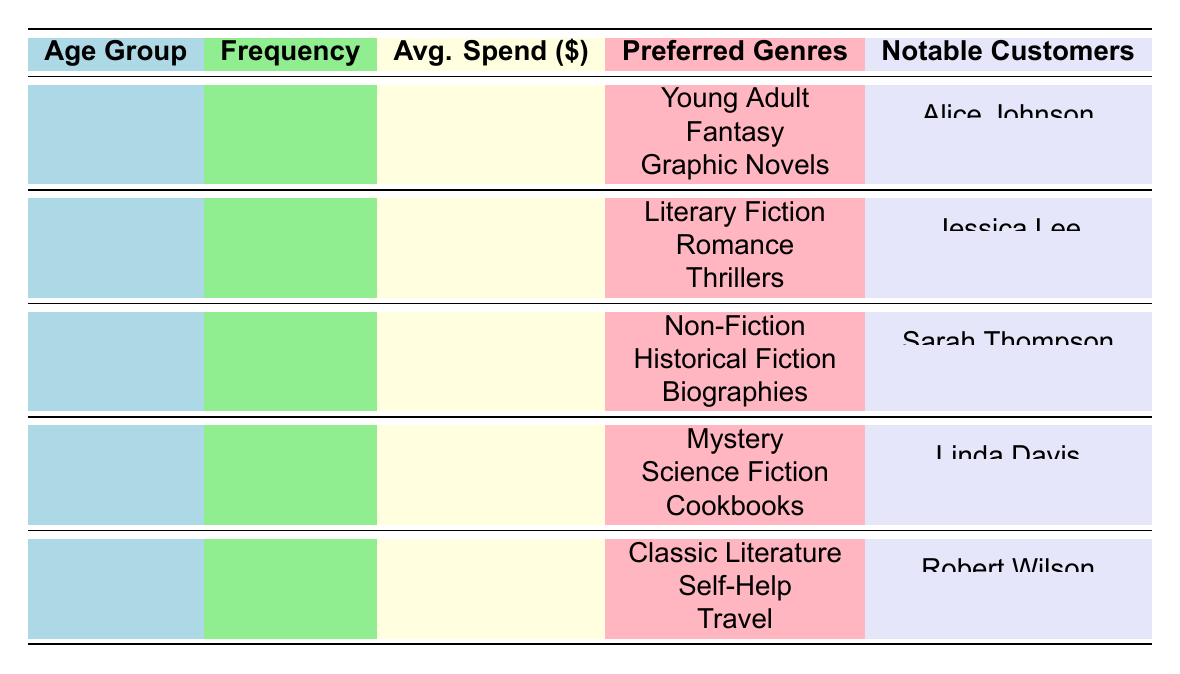What is the average spend for the 25-34 age group? The table shows that the average spend for the 25-34 age group is 45.
Answer: 45 Which age group purchases books weekly? By examining the frequency column, the 18-24 age group is the only group that purchases books weekly.
Answer: 18-24 How many notable customers are in the 35-44 age group? The 35-44 age group has two notable customers listed in the table: Sarah Thompson and David Brown.
Answer: 2 What is the average spend for customers aged 55 and above? The table indicates that customers aged 55 and above have an average spend of 70.
Answer: 70 Do customers aged 45-54 prefer Romance as a genre? Looking at the preferred genres for the 45-54 age group, they prefer Mystery, Science Fiction, and Cookbooks; Romance is not listed, so the answer is no.
Answer: No What is the difference in average spend between the 18-24 and 35-44 age groups? The average spend for the 18-24 age group is 30, and for the 35-44 age group, it is 60. The difference is 60 - 30 = 30.
Answer: 30 Which age group has the highest average spend? The 55+ age group has the highest average spend listed as 70, compared to all other age groups.
Answer: 55+ What is the purchasing frequency of the 45-54 age group? The table shows that the purchasing frequency of the 45-54 age group is monthly.
Answer: Monthly Which genres are preferred by customers aged 25-34? The preferred genres for the 25-34 age group are Literary Fiction, Romance, and Thrillers according to the table.
Answer: Literary Fiction, Romance, Thrillers How many groups have a monthly purchasing frequency? By counting in the frequency column, the 35-44 and 45-54 age groups both have a monthly purchasing frequency, making it two groups.
Answer: 2 